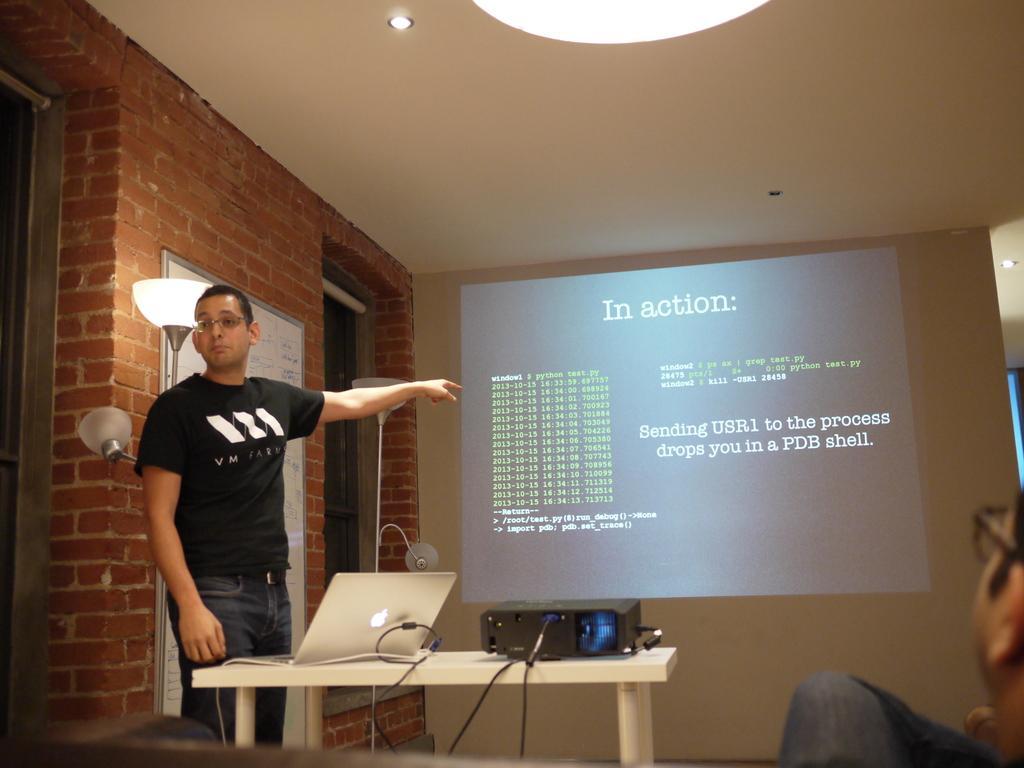Could you give a brief overview of what you see in this image? This is an image clicked inside the room. On the left side there is a man wearing black color t-shirt and standing and pointing out at the screen. On the bottom of the image there is a table, on the table there is a laptop and one projector. On the right corner of the image I can see a person's head and leg. On the left side there is a wall and one board is attached to that wall. 